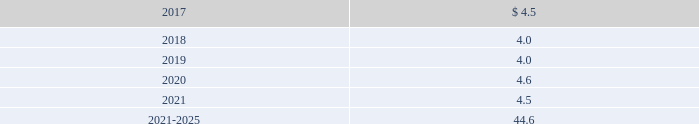Edwards lifesciences corporation notes to consolidated financial statements ( continued ) 12 .
Employee benefit plans ( continued ) equity and debt securities are valued at fair value based on quoted market prices reported on the active markets on which the individual securities are traded .
The insurance contracts are valued at the cash surrender value of the contracts , which is deemed to approximate its fair value .
The following benefit payments , which reflect expected future service , as appropriate , at december 31 , 2016 , are expected to be paid ( in millions ) : .
As of december 31 , 2016 , expected employer contributions for 2017 are $ 6.1 million .
Defined contribution plans the company 2019s employees in the united states and puerto rico are eligible to participate in a qualified defined contribution plan .
In the united states , participants may contribute up to 25% ( 25 % ) of their eligible compensation ( subject to tax code limitation ) to the plan .
Edwards lifesciences matches the first 3% ( 3 % ) of the participant 2019s annual eligible compensation contributed to the plan on a dollar-for-dollar basis .
Edwards lifesciences matches the next 2% ( 2 % ) of the participant 2019s annual eligible compensation to the plan on a 50% ( 50 % ) basis .
In puerto rico , participants may contribute up to 25% ( 25 % ) of their annual compensation ( subject to tax code limitation ) to the plan .
Edwards lifesciences matches the first 4% ( 4 % ) of participant 2019s annual eligible compensation contributed to the plan on a 50% ( 50 % ) basis .
The company also provides a 2% ( 2 % ) profit sharing contribution calculated on eligible earnings for each employee .
Matching contributions relating to edwards lifesciences employees were $ 17.3 million , $ 15.3 million , and $ 12.8 million in 2016 , 2015 , and 2014 , respectively .
The company also has nonqualified deferred compensation plans for a select group of employees .
The plans provide eligible participants the opportunity to defer eligible compensation to future dates specified by the participant with a return based on investment alternatives selected by the participant .
The amount accrued under these nonqualified plans was $ 46.7 million and $ 35.5 million at december 31 , 2016 and 2015 , respectively .
13 .
Common stock treasury stock in july 2014 , the board of directors approved a stock repurchase program authorizing the company to purchase up to $ 750.0 million of the company 2019s common stock .
In november 2016 , the board of directors approved a new stock repurchase program providing for an additional $ 1.0 billion of repurchases of our common stock .
The repurchase programs do not have an expiration date .
Stock repurchased under these programs may be used to offset obligations under the company 2019s employee stock-based benefit programs and stock-based business acquisitions , and will reduce the total shares outstanding .
During 2016 , 2015 , and 2014 , the company repurchased 7.3 million , 2.6 million , and 4.4 million shares , respectively , at an aggregate cost of $ 662.3 million , $ 280.1 million , and $ 300.9 million , respectively , including .
During 2016 what was the average price paid for the shares repurchased by the company? 
Computations: (280.1 / 2.6)
Answer: 107.73077. 